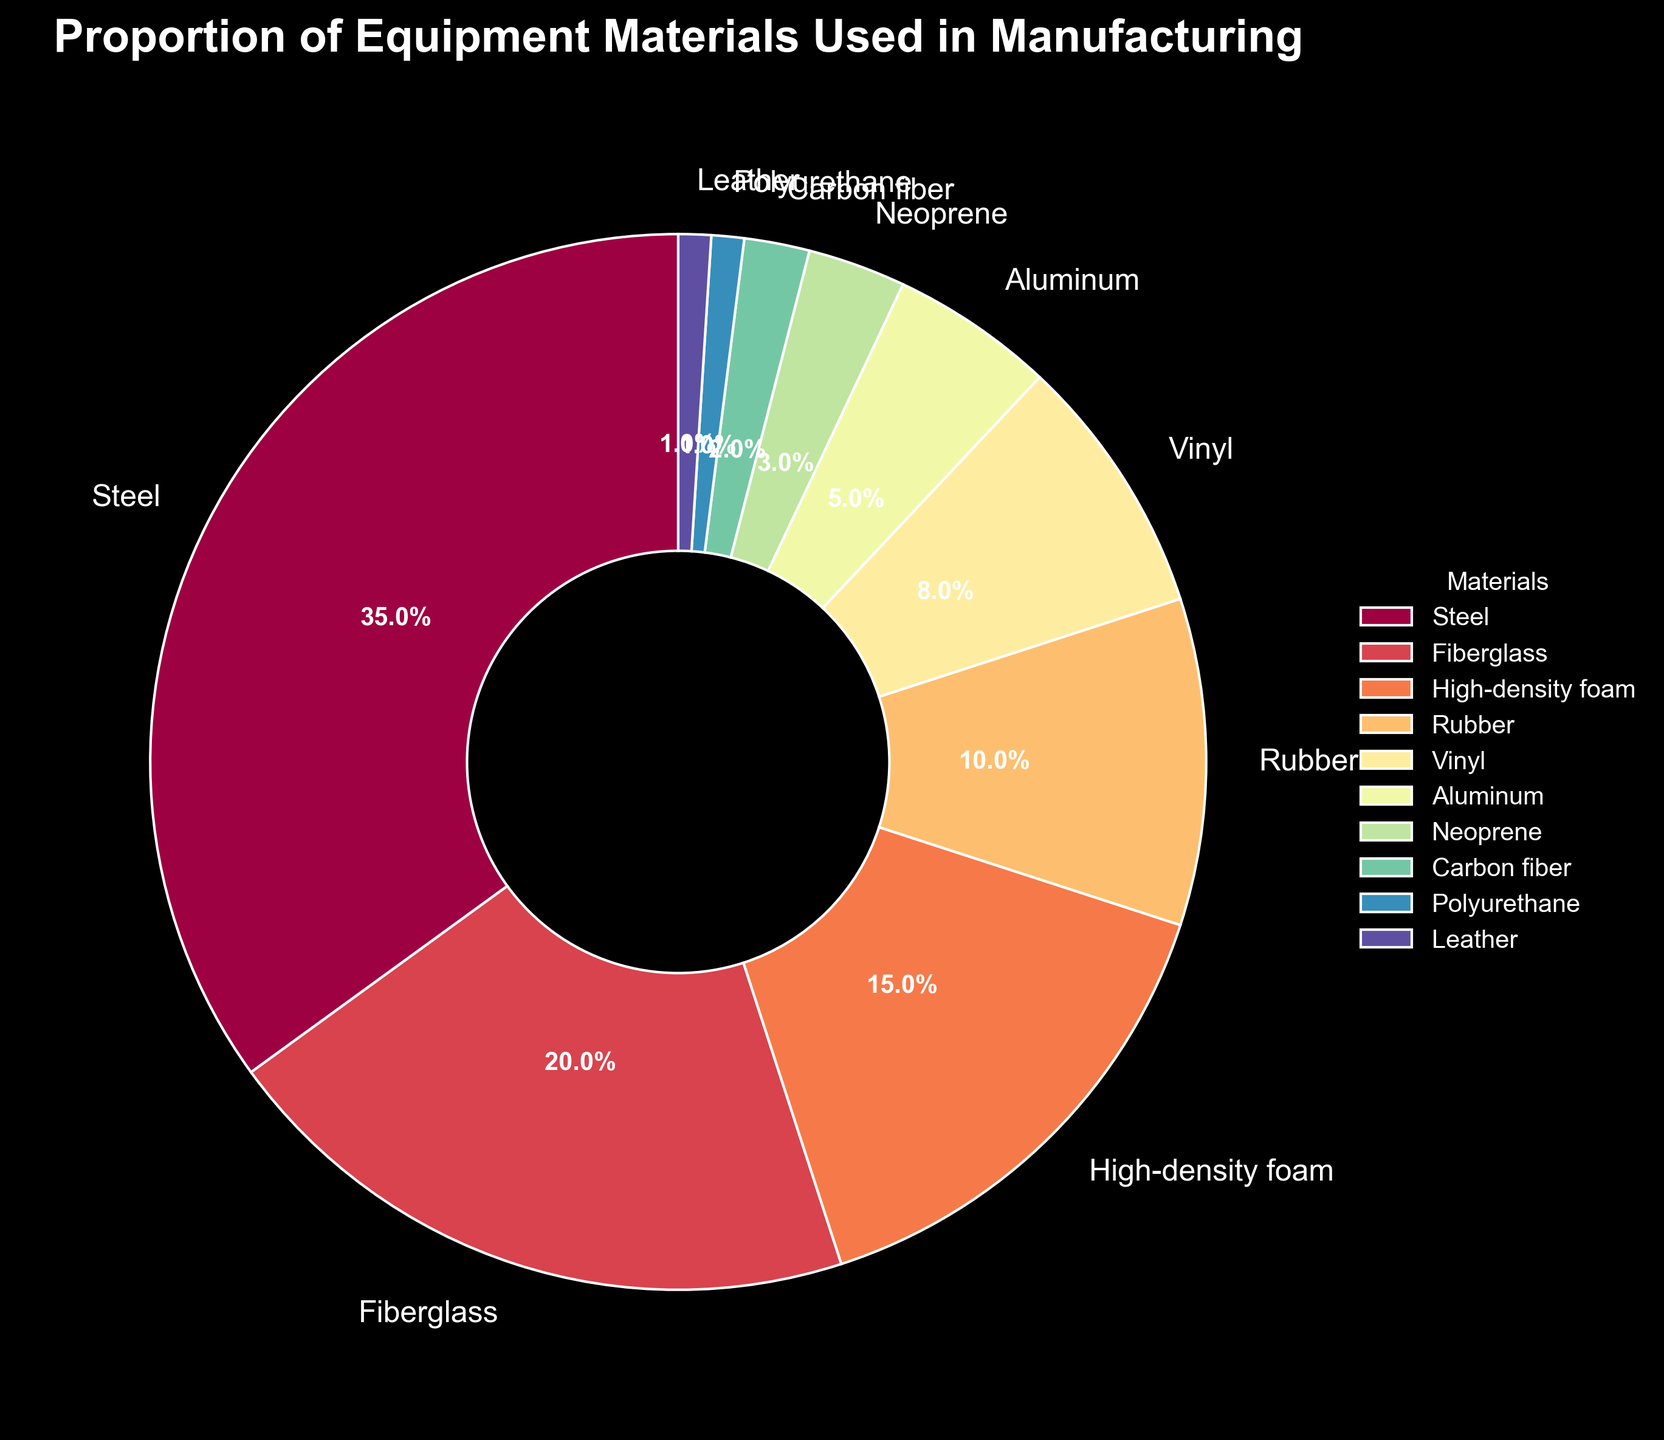What material makes up the largest proportion of the equipment materials? We look at the pie chart and observe which material has the largest slice. By seeing the percentages, Steel, with 35%, is the largest proportion.
Answer: Steel Which two materials together make up one-quarter of the total proportion? We need to find two materials whose combined percentages add up to around 25%. High-density foam is 15%, and Rubber is 10%, together making 25%.
Answer: High-density foam and Rubber How much more proportion does Steel have compared to Fiberglass? By observing the chart, Steel is 35% and Fiberglass is 20%. The difference is 35% - 20% = 15%.
Answer: 15% Which material has a smaller proportion than Vinyl but larger than Neoprene? By checking the percentages, Vinyl is 8%, Neoprene is 3%. Aluminum at 5% fits between them.
Answer: Aluminum What is the combined proportion of the materials contributing less than 5% each? We look at materials with proportions below 5%: Neoprene (3%), Carbon fiber (2%), Polyurethane (1%), and Leather (1%). Adding them: 3% + 2% + 1% + 1% = 7%.
Answer: 7% Identify the materials that together make up more than half of the proportion. Sum the materials in descending order until we exceed 50%. Steel (35%) + Fiberglass (20%) = 55%.
Answer: Steel and Fiberglass What proportion of materials used is either Rubber or Vinyl? Rubber is 10% and Vinyl is 8%. Adding them gives 10% + 8% = 18%.
Answer: 18% Rank the materials from most used to least used based on their proportions. By checking the percentages: Steel (35%), Fiberglass (20%), High-density foam (15%), Rubber (10%), Vinyl (8%), Aluminum (5%), Neoprene (3%), Carbon fiber (2%), Polyurethane (1%), Leather (1%).
Answer: Steel, Fiberglass, High-density foam, Rubber, Vinyl, Aluminum, Neoprene, Carbon fiber, Polyurethane, Leather 